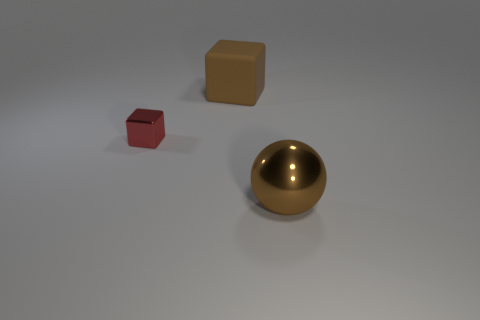There is a large cube that is the same color as the metallic sphere; what material is it?
Your answer should be compact. Rubber. How many objects are small purple rubber balls or metal objects that are right of the large brown matte thing?
Your answer should be compact. 1. What is the large cube made of?
Keep it short and to the point. Rubber. What is the material of the red thing that is the same shape as the large brown rubber object?
Offer a very short reply. Metal. What color is the cube that is in front of the big brown object that is to the left of the big brown metallic object?
Provide a short and direct response. Red. What number of rubber objects are large spheres or big cyan spheres?
Your answer should be very brief. 0. Is the material of the tiny thing the same as the large brown block?
Provide a succinct answer. No. There is a brown object that is behind the shiny thing to the left of the large ball; what is its material?
Your answer should be compact. Rubber. How many small things are metallic blocks or brown rubber things?
Provide a succinct answer. 1. How big is the ball?
Your answer should be very brief. Large. 